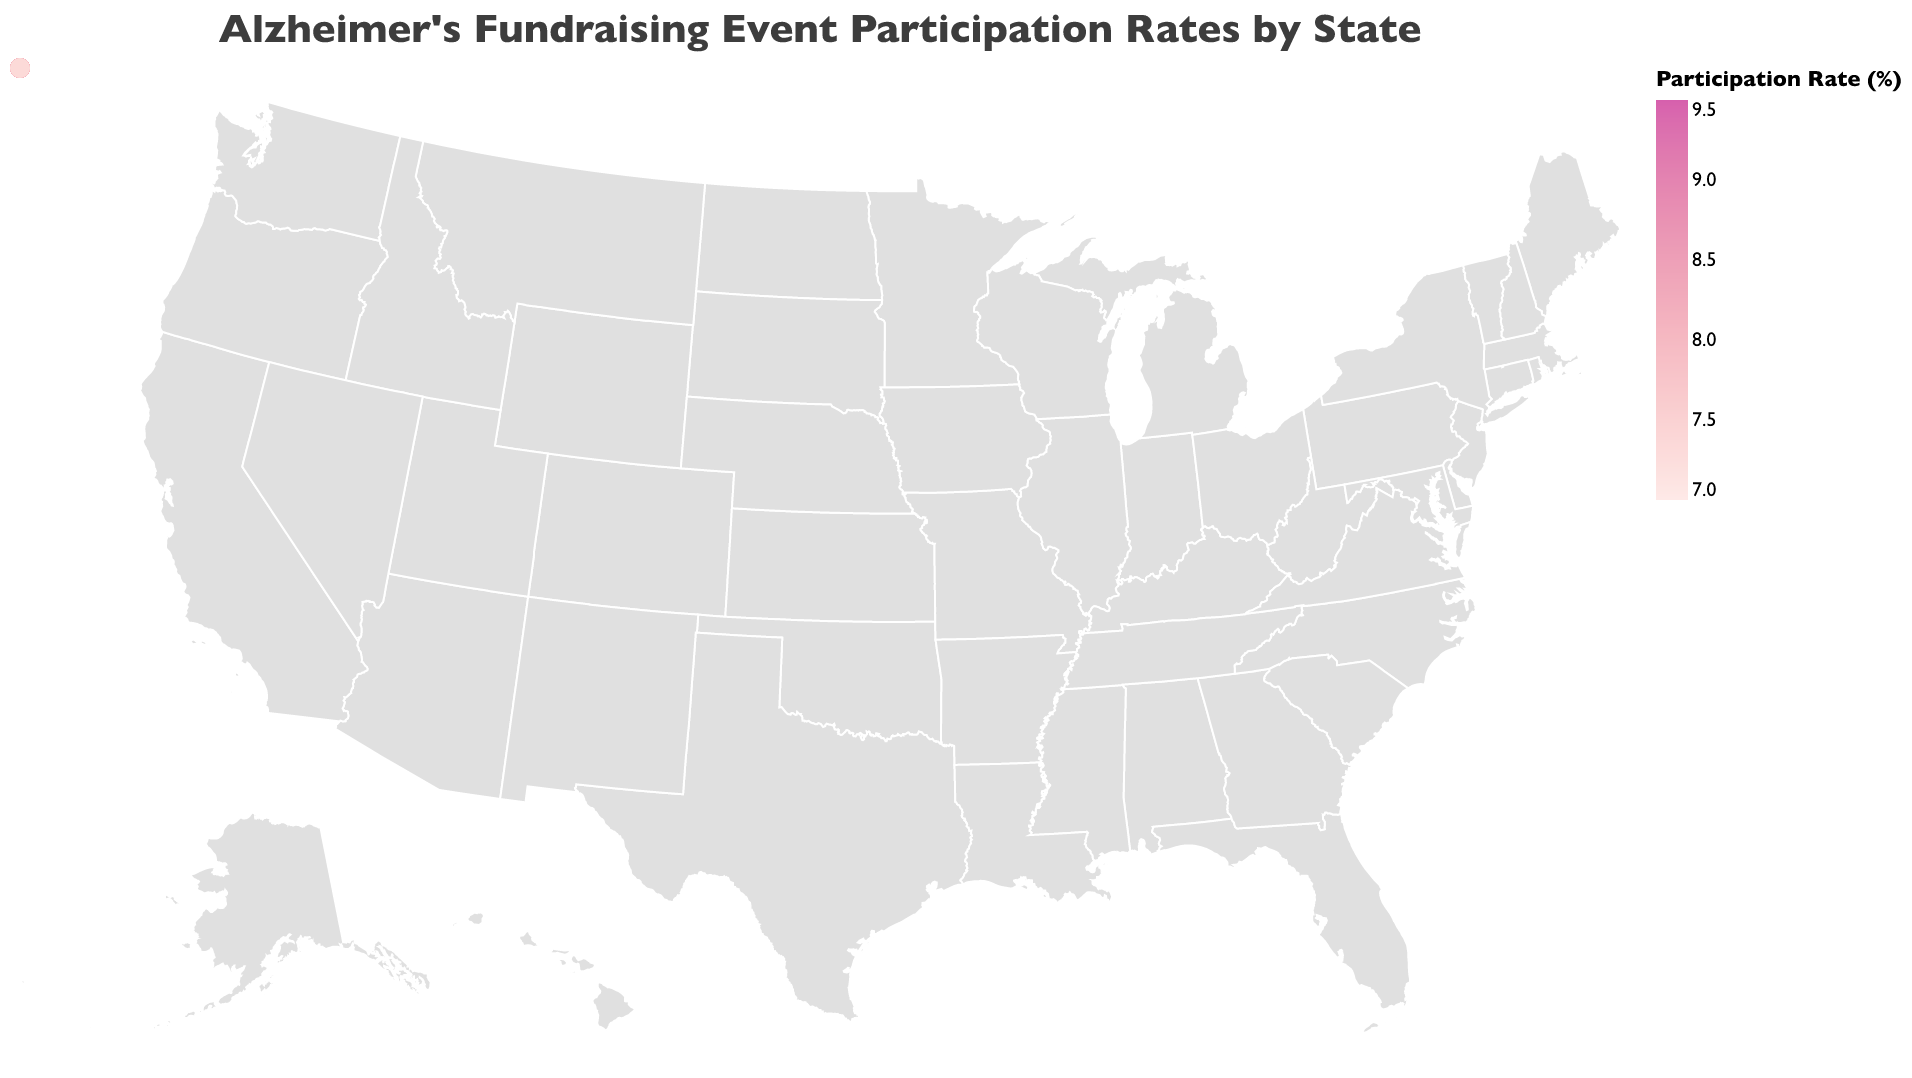What's the title of the figure? The title is at the top of the figure and provides a brief description of what the figure represents.
Answer: Alzheimer's Fundraising Event Participation Rates by State Which state has the highest participation rate? Look for the state with the highest numeric value in the legend or on the map itself.
Answer: Massachusetts Which states have participation rates above 9%? Locate the states on the map or in the legend that have participation rates above the 9% threshold.
Answer: Florida, Massachusetts What is the participation rate in Alabama? Identify Alabama on the map and read the participation rate from the tooltip or color gradient.
Answer: 7.1 Compare the participation rates of California and Texas. Find both California and Texas on the map, note their participation rates, and compare.
Answer: California: 8.2, Texas: 7.5 What is the difference in participation rates between Washington and Arizona? Subtract the participation rate of Arizona from that of Washington.
Answer: 8.9 - 7.7 = 1.2 How many states have a participation rate above 8.5%? Count the number of states on the map or from data points in the legend that exceeds an 8.5% participation rate.
Answer: 6 Is there a visible trend in participation rates between neighboring states in the Southeast? Examine the color gradient and participation rates of states in the Southeast region such as Alabama, Georgia, South Carolina, North Carolina, and Florida to note any trends.
Answer: Generally lower What is the average participation rate in the Midwest (using states Illinois, Indiana, Ohio, Michigan, and Missouri)? Add up the participation rates of Illinois, Indiana, Ohio, Michigan, and Missouri, then divide by 5 to find the average.
Answer: (7.9 + 7.2 + 7.6 + 7.8 + 7.3) / 5 = 7.56 Given the participation rates, which region appears to have the most consistent rates? Evaluate the consistency of participation rates by visually determining where similar colors (rates) are grouped together geographically.
Answer: The Northeast 